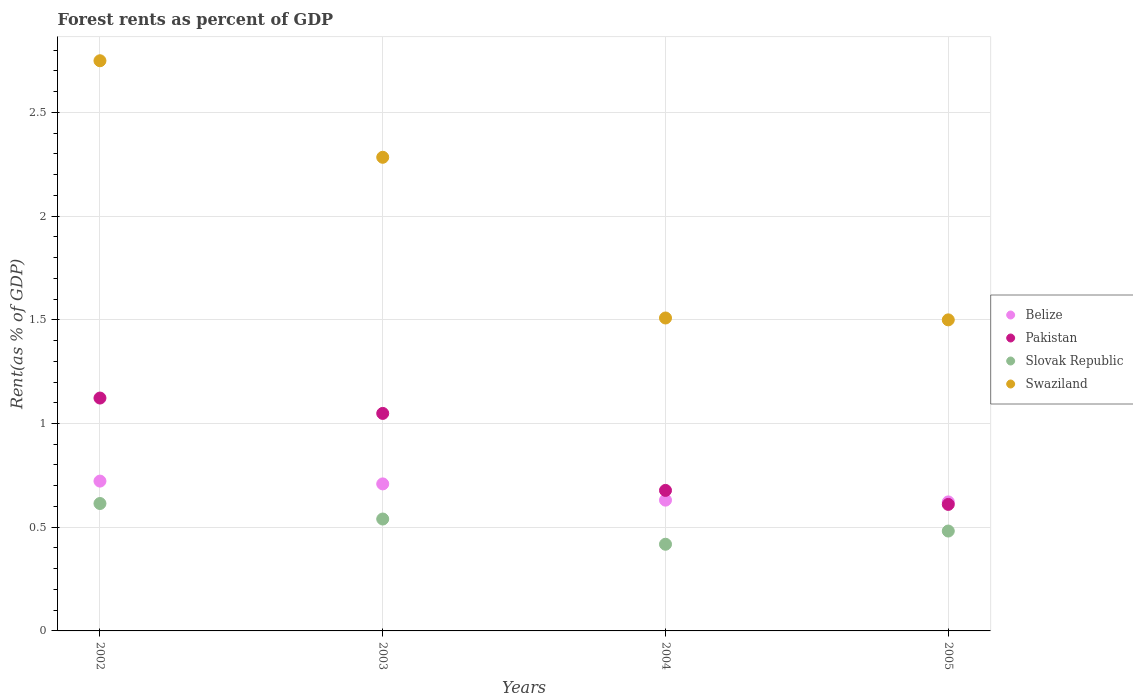How many different coloured dotlines are there?
Provide a short and direct response. 4. Is the number of dotlines equal to the number of legend labels?
Keep it short and to the point. Yes. What is the forest rent in Slovak Republic in 2003?
Your answer should be very brief. 0.54. Across all years, what is the maximum forest rent in Pakistan?
Make the answer very short. 1.12. Across all years, what is the minimum forest rent in Belize?
Your response must be concise. 0.62. In which year was the forest rent in Pakistan maximum?
Offer a terse response. 2002. What is the total forest rent in Swaziland in the graph?
Your answer should be very brief. 8.04. What is the difference between the forest rent in Slovak Republic in 2004 and that in 2005?
Your response must be concise. -0.06. What is the difference between the forest rent in Belize in 2002 and the forest rent in Pakistan in 2005?
Provide a succinct answer. 0.11. What is the average forest rent in Slovak Republic per year?
Make the answer very short. 0.51. In the year 2003, what is the difference between the forest rent in Belize and forest rent in Pakistan?
Offer a very short reply. -0.34. What is the ratio of the forest rent in Belize in 2002 to that in 2004?
Offer a terse response. 1.15. Is the forest rent in Swaziland in 2002 less than that in 2003?
Offer a terse response. No. What is the difference between the highest and the second highest forest rent in Swaziland?
Your answer should be very brief. 0.47. What is the difference between the highest and the lowest forest rent in Pakistan?
Your response must be concise. 0.51. Is it the case that in every year, the sum of the forest rent in Belize and forest rent in Slovak Republic  is greater than the sum of forest rent in Pakistan and forest rent in Swaziland?
Provide a short and direct response. No. Is it the case that in every year, the sum of the forest rent in Belize and forest rent in Pakistan  is greater than the forest rent in Slovak Republic?
Provide a succinct answer. Yes. Does the forest rent in Pakistan monotonically increase over the years?
Give a very brief answer. No. How many dotlines are there?
Ensure brevity in your answer.  4. What is the difference between two consecutive major ticks on the Y-axis?
Ensure brevity in your answer.  0.5. Are the values on the major ticks of Y-axis written in scientific E-notation?
Your answer should be very brief. No. Does the graph contain grids?
Give a very brief answer. Yes. Where does the legend appear in the graph?
Ensure brevity in your answer.  Center right. What is the title of the graph?
Your response must be concise. Forest rents as percent of GDP. What is the label or title of the X-axis?
Offer a terse response. Years. What is the label or title of the Y-axis?
Make the answer very short. Rent(as % of GDP). What is the Rent(as % of GDP) of Belize in 2002?
Your response must be concise. 0.72. What is the Rent(as % of GDP) of Pakistan in 2002?
Provide a succinct answer. 1.12. What is the Rent(as % of GDP) in Slovak Republic in 2002?
Your response must be concise. 0.61. What is the Rent(as % of GDP) of Swaziland in 2002?
Ensure brevity in your answer.  2.75. What is the Rent(as % of GDP) of Belize in 2003?
Make the answer very short. 0.71. What is the Rent(as % of GDP) in Pakistan in 2003?
Offer a terse response. 1.05. What is the Rent(as % of GDP) of Slovak Republic in 2003?
Ensure brevity in your answer.  0.54. What is the Rent(as % of GDP) of Swaziland in 2003?
Offer a terse response. 2.28. What is the Rent(as % of GDP) in Belize in 2004?
Provide a succinct answer. 0.63. What is the Rent(as % of GDP) of Pakistan in 2004?
Ensure brevity in your answer.  0.68. What is the Rent(as % of GDP) in Slovak Republic in 2004?
Your response must be concise. 0.42. What is the Rent(as % of GDP) of Swaziland in 2004?
Ensure brevity in your answer.  1.51. What is the Rent(as % of GDP) in Belize in 2005?
Your response must be concise. 0.62. What is the Rent(as % of GDP) of Pakistan in 2005?
Your response must be concise. 0.61. What is the Rent(as % of GDP) in Slovak Republic in 2005?
Give a very brief answer. 0.48. What is the Rent(as % of GDP) in Swaziland in 2005?
Provide a succinct answer. 1.5. Across all years, what is the maximum Rent(as % of GDP) of Belize?
Give a very brief answer. 0.72. Across all years, what is the maximum Rent(as % of GDP) of Pakistan?
Your answer should be compact. 1.12. Across all years, what is the maximum Rent(as % of GDP) in Slovak Republic?
Ensure brevity in your answer.  0.61. Across all years, what is the maximum Rent(as % of GDP) in Swaziland?
Your answer should be compact. 2.75. Across all years, what is the minimum Rent(as % of GDP) of Belize?
Provide a succinct answer. 0.62. Across all years, what is the minimum Rent(as % of GDP) of Pakistan?
Provide a succinct answer. 0.61. Across all years, what is the minimum Rent(as % of GDP) in Slovak Republic?
Provide a short and direct response. 0.42. Across all years, what is the minimum Rent(as % of GDP) in Swaziland?
Provide a succinct answer. 1.5. What is the total Rent(as % of GDP) in Belize in the graph?
Offer a terse response. 2.68. What is the total Rent(as % of GDP) in Pakistan in the graph?
Provide a succinct answer. 3.46. What is the total Rent(as % of GDP) in Slovak Republic in the graph?
Your answer should be very brief. 2.05. What is the total Rent(as % of GDP) in Swaziland in the graph?
Ensure brevity in your answer.  8.04. What is the difference between the Rent(as % of GDP) of Belize in 2002 and that in 2003?
Provide a succinct answer. 0.01. What is the difference between the Rent(as % of GDP) in Pakistan in 2002 and that in 2003?
Offer a very short reply. 0.07. What is the difference between the Rent(as % of GDP) in Slovak Republic in 2002 and that in 2003?
Keep it short and to the point. 0.07. What is the difference between the Rent(as % of GDP) in Swaziland in 2002 and that in 2003?
Ensure brevity in your answer.  0.47. What is the difference between the Rent(as % of GDP) in Belize in 2002 and that in 2004?
Offer a terse response. 0.09. What is the difference between the Rent(as % of GDP) of Pakistan in 2002 and that in 2004?
Offer a very short reply. 0.45. What is the difference between the Rent(as % of GDP) in Slovak Republic in 2002 and that in 2004?
Provide a short and direct response. 0.2. What is the difference between the Rent(as % of GDP) in Swaziland in 2002 and that in 2004?
Offer a very short reply. 1.24. What is the difference between the Rent(as % of GDP) of Belize in 2002 and that in 2005?
Your response must be concise. 0.1. What is the difference between the Rent(as % of GDP) of Pakistan in 2002 and that in 2005?
Ensure brevity in your answer.  0.51. What is the difference between the Rent(as % of GDP) of Slovak Republic in 2002 and that in 2005?
Keep it short and to the point. 0.13. What is the difference between the Rent(as % of GDP) of Swaziland in 2002 and that in 2005?
Offer a terse response. 1.25. What is the difference between the Rent(as % of GDP) in Belize in 2003 and that in 2004?
Ensure brevity in your answer.  0.08. What is the difference between the Rent(as % of GDP) of Pakistan in 2003 and that in 2004?
Ensure brevity in your answer.  0.37. What is the difference between the Rent(as % of GDP) in Slovak Republic in 2003 and that in 2004?
Provide a short and direct response. 0.12. What is the difference between the Rent(as % of GDP) of Swaziland in 2003 and that in 2004?
Offer a terse response. 0.77. What is the difference between the Rent(as % of GDP) in Belize in 2003 and that in 2005?
Your answer should be very brief. 0.09. What is the difference between the Rent(as % of GDP) of Pakistan in 2003 and that in 2005?
Your answer should be very brief. 0.44. What is the difference between the Rent(as % of GDP) of Slovak Republic in 2003 and that in 2005?
Offer a very short reply. 0.06. What is the difference between the Rent(as % of GDP) of Swaziland in 2003 and that in 2005?
Provide a short and direct response. 0.78. What is the difference between the Rent(as % of GDP) of Belize in 2004 and that in 2005?
Make the answer very short. 0.01. What is the difference between the Rent(as % of GDP) in Pakistan in 2004 and that in 2005?
Offer a very short reply. 0.07. What is the difference between the Rent(as % of GDP) of Slovak Republic in 2004 and that in 2005?
Provide a succinct answer. -0.06. What is the difference between the Rent(as % of GDP) of Swaziland in 2004 and that in 2005?
Provide a succinct answer. 0.01. What is the difference between the Rent(as % of GDP) in Belize in 2002 and the Rent(as % of GDP) in Pakistan in 2003?
Offer a very short reply. -0.33. What is the difference between the Rent(as % of GDP) of Belize in 2002 and the Rent(as % of GDP) of Slovak Republic in 2003?
Make the answer very short. 0.18. What is the difference between the Rent(as % of GDP) of Belize in 2002 and the Rent(as % of GDP) of Swaziland in 2003?
Give a very brief answer. -1.56. What is the difference between the Rent(as % of GDP) of Pakistan in 2002 and the Rent(as % of GDP) of Slovak Republic in 2003?
Ensure brevity in your answer.  0.58. What is the difference between the Rent(as % of GDP) of Pakistan in 2002 and the Rent(as % of GDP) of Swaziland in 2003?
Your answer should be compact. -1.16. What is the difference between the Rent(as % of GDP) in Slovak Republic in 2002 and the Rent(as % of GDP) in Swaziland in 2003?
Provide a short and direct response. -1.67. What is the difference between the Rent(as % of GDP) of Belize in 2002 and the Rent(as % of GDP) of Pakistan in 2004?
Provide a succinct answer. 0.04. What is the difference between the Rent(as % of GDP) in Belize in 2002 and the Rent(as % of GDP) in Slovak Republic in 2004?
Offer a very short reply. 0.3. What is the difference between the Rent(as % of GDP) of Belize in 2002 and the Rent(as % of GDP) of Swaziland in 2004?
Your answer should be very brief. -0.79. What is the difference between the Rent(as % of GDP) of Pakistan in 2002 and the Rent(as % of GDP) of Slovak Republic in 2004?
Your answer should be very brief. 0.7. What is the difference between the Rent(as % of GDP) in Pakistan in 2002 and the Rent(as % of GDP) in Swaziland in 2004?
Make the answer very short. -0.39. What is the difference between the Rent(as % of GDP) in Slovak Republic in 2002 and the Rent(as % of GDP) in Swaziland in 2004?
Give a very brief answer. -0.89. What is the difference between the Rent(as % of GDP) in Belize in 2002 and the Rent(as % of GDP) in Pakistan in 2005?
Your answer should be compact. 0.11. What is the difference between the Rent(as % of GDP) in Belize in 2002 and the Rent(as % of GDP) in Slovak Republic in 2005?
Give a very brief answer. 0.24. What is the difference between the Rent(as % of GDP) in Belize in 2002 and the Rent(as % of GDP) in Swaziland in 2005?
Keep it short and to the point. -0.78. What is the difference between the Rent(as % of GDP) of Pakistan in 2002 and the Rent(as % of GDP) of Slovak Republic in 2005?
Your response must be concise. 0.64. What is the difference between the Rent(as % of GDP) of Pakistan in 2002 and the Rent(as % of GDP) of Swaziland in 2005?
Give a very brief answer. -0.38. What is the difference between the Rent(as % of GDP) of Slovak Republic in 2002 and the Rent(as % of GDP) of Swaziland in 2005?
Keep it short and to the point. -0.89. What is the difference between the Rent(as % of GDP) of Belize in 2003 and the Rent(as % of GDP) of Pakistan in 2004?
Offer a terse response. 0.03. What is the difference between the Rent(as % of GDP) in Belize in 2003 and the Rent(as % of GDP) in Slovak Republic in 2004?
Offer a very short reply. 0.29. What is the difference between the Rent(as % of GDP) of Belize in 2003 and the Rent(as % of GDP) of Swaziland in 2004?
Offer a very short reply. -0.8. What is the difference between the Rent(as % of GDP) in Pakistan in 2003 and the Rent(as % of GDP) in Slovak Republic in 2004?
Your answer should be very brief. 0.63. What is the difference between the Rent(as % of GDP) of Pakistan in 2003 and the Rent(as % of GDP) of Swaziland in 2004?
Provide a short and direct response. -0.46. What is the difference between the Rent(as % of GDP) in Slovak Republic in 2003 and the Rent(as % of GDP) in Swaziland in 2004?
Provide a succinct answer. -0.97. What is the difference between the Rent(as % of GDP) in Belize in 2003 and the Rent(as % of GDP) in Pakistan in 2005?
Your answer should be very brief. 0.1. What is the difference between the Rent(as % of GDP) in Belize in 2003 and the Rent(as % of GDP) in Slovak Republic in 2005?
Provide a succinct answer. 0.23. What is the difference between the Rent(as % of GDP) in Belize in 2003 and the Rent(as % of GDP) in Swaziland in 2005?
Make the answer very short. -0.79. What is the difference between the Rent(as % of GDP) of Pakistan in 2003 and the Rent(as % of GDP) of Slovak Republic in 2005?
Give a very brief answer. 0.57. What is the difference between the Rent(as % of GDP) of Pakistan in 2003 and the Rent(as % of GDP) of Swaziland in 2005?
Provide a succinct answer. -0.45. What is the difference between the Rent(as % of GDP) in Slovak Republic in 2003 and the Rent(as % of GDP) in Swaziland in 2005?
Provide a short and direct response. -0.96. What is the difference between the Rent(as % of GDP) in Belize in 2004 and the Rent(as % of GDP) in Pakistan in 2005?
Offer a very short reply. 0.02. What is the difference between the Rent(as % of GDP) in Belize in 2004 and the Rent(as % of GDP) in Slovak Republic in 2005?
Offer a terse response. 0.15. What is the difference between the Rent(as % of GDP) of Belize in 2004 and the Rent(as % of GDP) of Swaziland in 2005?
Give a very brief answer. -0.87. What is the difference between the Rent(as % of GDP) in Pakistan in 2004 and the Rent(as % of GDP) in Slovak Republic in 2005?
Your answer should be compact. 0.2. What is the difference between the Rent(as % of GDP) in Pakistan in 2004 and the Rent(as % of GDP) in Swaziland in 2005?
Provide a short and direct response. -0.82. What is the difference between the Rent(as % of GDP) in Slovak Republic in 2004 and the Rent(as % of GDP) in Swaziland in 2005?
Your answer should be compact. -1.08. What is the average Rent(as % of GDP) of Belize per year?
Provide a succinct answer. 0.67. What is the average Rent(as % of GDP) in Pakistan per year?
Give a very brief answer. 0.86. What is the average Rent(as % of GDP) in Slovak Republic per year?
Give a very brief answer. 0.51. What is the average Rent(as % of GDP) in Swaziland per year?
Offer a terse response. 2.01. In the year 2002, what is the difference between the Rent(as % of GDP) in Belize and Rent(as % of GDP) in Pakistan?
Give a very brief answer. -0.4. In the year 2002, what is the difference between the Rent(as % of GDP) of Belize and Rent(as % of GDP) of Slovak Republic?
Provide a short and direct response. 0.11. In the year 2002, what is the difference between the Rent(as % of GDP) of Belize and Rent(as % of GDP) of Swaziland?
Provide a succinct answer. -2.03. In the year 2002, what is the difference between the Rent(as % of GDP) in Pakistan and Rent(as % of GDP) in Slovak Republic?
Provide a short and direct response. 0.51. In the year 2002, what is the difference between the Rent(as % of GDP) of Pakistan and Rent(as % of GDP) of Swaziland?
Provide a succinct answer. -1.63. In the year 2002, what is the difference between the Rent(as % of GDP) of Slovak Republic and Rent(as % of GDP) of Swaziland?
Make the answer very short. -2.13. In the year 2003, what is the difference between the Rent(as % of GDP) of Belize and Rent(as % of GDP) of Pakistan?
Make the answer very short. -0.34. In the year 2003, what is the difference between the Rent(as % of GDP) in Belize and Rent(as % of GDP) in Slovak Republic?
Your answer should be very brief. 0.17. In the year 2003, what is the difference between the Rent(as % of GDP) in Belize and Rent(as % of GDP) in Swaziland?
Offer a terse response. -1.57. In the year 2003, what is the difference between the Rent(as % of GDP) of Pakistan and Rent(as % of GDP) of Slovak Republic?
Offer a terse response. 0.51. In the year 2003, what is the difference between the Rent(as % of GDP) in Pakistan and Rent(as % of GDP) in Swaziland?
Provide a succinct answer. -1.23. In the year 2003, what is the difference between the Rent(as % of GDP) in Slovak Republic and Rent(as % of GDP) in Swaziland?
Your answer should be compact. -1.74. In the year 2004, what is the difference between the Rent(as % of GDP) in Belize and Rent(as % of GDP) in Pakistan?
Offer a very short reply. -0.05. In the year 2004, what is the difference between the Rent(as % of GDP) in Belize and Rent(as % of GDP) in Slovak Republic?
Ensure brevity in your answer.  0.21. In the year 2004, what is the difference between the Rent(as % of GDP) of Belize and Rent(as % of GDP) of Swaziland?
Keep it short and to the point. -0.88. In the year 2004, what is the difference between the Rent(as % of GDP) of Pakistan and Rent(as % of GDP) of Slovak Republic?
Give a very brief answer. 0.26. In the year 2004, what is the difference between the Rent(as % of GDP) in Pakistan and Rent(as % of GDP) in Swaziland?
Your response must be concise. -0.83. In the year 2004, what is the difference between the Rent(as % of GDP) in Slovak Republic and Rent(as % of GDP) in Swaziland?
Make the answer very short. -1.09. In the year 2005, what is the difference between the Rent(as % of GDP) in Belize and Rent(as % of GDP) in Pakistan?
Provide a succinct answer. 0.01. In the year 2005, what is the difference between the Rent(as % of GDP) of Belize and Rent(as % of GDP) of Slovak Republic?
Provide a succinct answer. 0.14. In the year 2005, what is the difference between the Rent(as % of GDP) of Belize and Rent(as % of GDP) of Swaziland?
Your answer should be compact. -0.88. In the year 2005, what is the difference between the Rent(as % of GDP) in Pakistan and Rent(as % of GDP) in Slovak Republic?
Provide a short and direct response. 0.13. In the year 2005, what is the difference between the Rent(as % of GDP) of Pakistan and Rent(as % of GDP) of Swaziland?
Your answer should be compact. -0.89. In the year 2005, what is the difference between the Rent(as % of GDP) of Slovak Republic and Rent(as % of GDP) of Swaziland?
Your response must be concise. -1.02. What is the ratio of the Rent(as % of GDP) of Pakistan in 2002 to that in 2003?
Give a very brief answer. 1.07. What is the ratio of the Rent(as % of GDP) in Slovak Republic in 2002 to that in 2003?
Your response must be concise. 1.14. What is the ratio of the Rent(as % of GDP) in Swaziland in 2002 to that in 2003?
Your answer should be compact. 1.2. What is the ratio of the Rent(as % of GDP) in Belize in 2002 to that in 2004?
Keep it short and to the point. 1.15. What is the ratio of the Rent(as % of GDP) of Pakistan in 2002 to that in 2004?
Ensure brevity in your answer.  1.66. What is the ratio of the Rent(as % of GDP) of Slovak Republic in 2002 to that in 2004?
Keep it short and to the point. 1.47. What is the ratio of the Rent(as % of GDP) in Swaziland in 2002 to that in 2004?
Offer a very short reply. 1.82. What is the ratio of the Rent(as % of GDP) in Belize in 2002 to that in 2005?
Keep it short and to the point. 1.16. What is the ratio of the Rent(as % of GDP) in Pakistan in 2002 to that in 2005?
Your answer should be compact. 1.84. What is the ratio of the Rent(as % of GDP) in Slovak Republic in 2002 to that in 2005?
Keep it short and to the point. 1.28. What is the ratio of the Rent(as % of GDP) of Swaziland in 2002 to that in 2005?
Your answer should be very brief. 1.83. What is the ratio of the Rent(as % of GDP) of Belize in 2003 to that in 2004?
Your answer should be compact. 1.12. What is the ratio of the Rent(as % of GDP) of Pakistan in 2003 to that in 2004?
Your answer should be compact. 1.55. What is the ratio of the Rent(as % of GDP) of Slovak Republic in 2003 to that in 2004?
Your answer should be very brief. 1.29. What is the ratio of the Rent(as % of GDP) of Swaziland in 2003 to that in 2004?
Provide a succinct answer. 1.51. What is the ratio of the Rent(as % of GDP) of Belize in 2003 to that in 2005?
Ensure brevity in your answer.  1.14. What is the ratio of the Rent(as % of GDP) of Pakistan in 2003 to that in 2005?
Offer a terse response. 1.72. What is the ratio of the Rent(as % of GDP) in Slovak Republic in 2003 to that in 2005?
Give a very brief answer. 1.12. What is the ratio of the Rent(as % of GDP) in Swaziland in 2003 to that in 2005?
Provide a succinct answer. 1.52. What is the ratio of the Rent(as % of GDP) of Belize in 2004 to that in 2005?
Your answer should be very brief. 1.01. What is the ratio of the Rent(as % of GDP) of Pakistan in 2004 to that in 2005?
Provide a succinct answer. 1.11. What is the ratio of the Rent(as % of GDP) in Slovak Republic in 2004 to that in 2005?
Provide a short and direct response. 0.87. What is the ratio of the Rent(as % of GDP) in Swaziland in 2004 to that in 2005?
Your answer should be very brief. 1.01. What is the difference between the highest and the second highest Rent(as % of GDP) in Belize?
Provide a succinct answer. 0.01. What is the difference between the highest and the second highest Rent(as % of GDP) of Pakistan?
Provide a short and direct response. 0.07. What is the difference between the highest and the second highest Rent(as % of GDP) in Slovak Republic?
Your answer should be compact. 0.07. What is the difference between the highest and the second highest Rent(as % of GDP) of Swaziland?
Offer a terse response. 0.47. What is the difference between the highest and the lowest Rent(as % of GDP) in Belize?
Offer a very short reply. 0.1. What is the difference between the highest and the lowest Rent(as % of GDP) in Pakistan?
Your response must be concise. 0.51. What is the difference between the highest and the lowest Rent(as % of GDP) of Slovak Republic?
Offer a terse response. 0.2. What is the difference between the highest and the lowest Rent(as % of GDP) in Swaziland?
Provide a succinct answer. 1.25. 